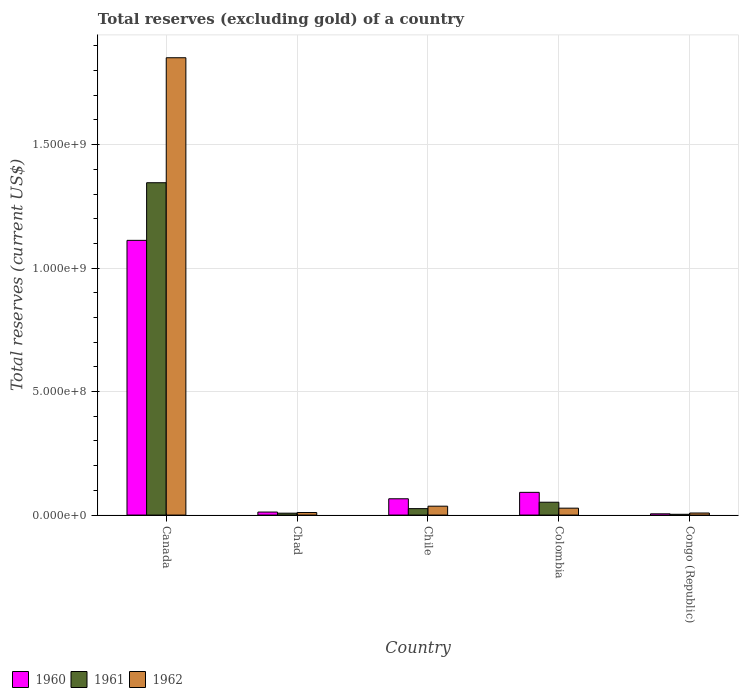How many groups of bars are there?
Make the answer very short. 5. Are the number of bars per tick equal to the number of legend labels?
Ensure brevity in your answer.  Yes. What is the label of the 5th group of bars from the left?
Your answer should be compact. Congo (Republic). In how many cases, is the number of bars for a given country not equal to the number of legend labels?
Offer a terse response. 0. What is the total reserves (excluding gold) in 1962 in Canada?
Make the answer very short. 1.85e+09. Across all countries, what is the maximum total reserves (excluding gold) in 1960?
Provide a succinct answer. 1.11e+09. Across all countries, what is the minimum total reserves (excluding gold) in 1962?
Your answer should be very brief. 8.38e+06. In which country was the total reserves (excluding gold) in 1962 minimum?
Your answer should be very brief. Congo (Republic). What is the total total reserves (excluding gold) in 1961 in the graph?
Provide a short and direct response. 1.43e+09. What is the difference between the total reserves (excluding gold) in 1960 in Colombia and that in Congo (Republic)?
Give a very brief answer. 8.69e+07. What is the difference between the total reserves (excluding gold) in 1960 in Colombia and the total reserves (excluding gold) in 1961 in Chile?
Make the answer very short. 6.59e+07. What is the average total reserves (excluding gold) in 1960 per country?
Provide a succinct answer. 2.58e+08. What is the difference between the total reserves (excluding gold) of/in 1960 and total reserves (excluding gold) of/in 1962 in Congo (Republic)?
Offer a terse response. -3.32e+06. In how many countries, is the total reserves (excluding gold) in 1962 greater than 1800000000 US$?
Provide a short and direct response. 1. What is the ratio of the total reserves (excluding gold) in 1962 in Chad to that in Colombia?
Your answer should be compact. 0.37. Is the total reserves (excluding gold) in 1961 in Chad less than that in Chile?
Offer a terse response. Yes. What is the difference between the highest and the second highest total reserves (excluding gold) in 1962?
Provide a succinct answer. 1.82e+09. What is the difference between the highest and the lowest total reserves (excluding gold) in 1962?
Ensure brevity in your answer.  1.84e+09. What does the 1st bar from the left in Canada represents?
Give a very brief answer. 1960. What is the difference between two consecutive major ticks on the Y-axis?
Give a very brief answer. 5.00e+08. Does the graph contain any zero values?
Ensure brevity in your answer.  No. Does the graph contain grids?
Your answer should be very brief. Yes. Where does the legend appear in the graph?
Provide a succinct answer. Bottom left. How many legend labels are there?
Offer a very short reply. 3. How are the legend labels stacked?
Keep it short and to the point. Horizontal. What is the title of the graph?
Your response must be concise. Total reserves (excluding gold) of a country. What is the label or title of the Y-axis?
Your answer should be very brief. Total reserves (current US$). What is the Total reserves (current US$) of 1960 in Canada?
Offer a terse response. 1.11e+09. What is the Total reserves (current US$) in 1961 in Canada?
Offer a terse response. 1.35e+09. What is the Total reserves (current US$) in 1962 in Canada?
Your response must be concise. 1.85e+09. What is the Total reserves (current US$) in 1960 in Chad?
Make the answer very short. 1.22e+07. What is the Total reserves (current US$) of 1961 in Chad?
Offer a terse response. 7.69e+06. What is the Total reserves (current US$) in 1962 in Chad?
Offer a very short reply. 1.03e+07. What is the Total reserves (current US$) in 1960 in Chile?
Your response must be concise. 6.60e+07. What is the Total reserves (current US$) of 1961 in Chile?
Offer a terse response. 2.61e+07. What is the Total reserves (current US$) in 1962 in Chile?
Provide a short and direct response. 3.60e+07. What is the Total reserves (current US$) in 1960 in Colombia?
Ensure brevity in your answer.  9.20e+07. What is the Total reserves (current US$) of 1961 in Colombia?
Keep it short and to the point. 5.20e+07. What is the Total reserves (current US$) in 1962 in Colombia?
Provide a short and direct response. 2.80e+07. What is the Total reserves (current US$) in 1960 in Congo (Republic)?
Provide a succinct answer. 5.06e+06. What is the Total reserves (current US$) of 1961 in Congo (Republic)?
Offer a terse response. 3.16e+06. What is the Total reserves (current US$) of 1962 in Congo (Republic)?
Your answer should be compact. 8.38e+06. Across all countries, what is the maximum Total reserves (current US$) of 1960?
Your response must be concise. 1.11e+09. Across all countries, what is the maximum Total reserves (current US$) of 1961?
Provide a succinct answer. 1.35e+09. Across all countries, what is the maximum Total reserves (current US$) of 1962?
Offer a very short reply. 1.85e+09. Across all countries, what is the minimum Total reserves (current US$) in 1960?
Your answer should be compact. 5.06e+06. Across all countries, what is the minimum Total reserves (current US$) of 1961?
Provide a short and direct response. 3.16e+06. Across all countries, what is the minimum Total reserves (current US$) of 1962?
Your answer should be compact. 8.38e+06. What is the total Total reserves (current US$) of 1960 in the graph?
Your answer should be compact. 1.29e+09. What is the total Total reserves (current US$) of 1961 in the graph?
Offer a very short reply. 1.43e+09. What is the total Total reserves (current US$) of 1962 in the graph?
Ensure brevity in your answer.  1.93e+09. What is the difference between the Total reserves (current US$) of 1960 in Canada and that in Chad?
Make the answer very short. 1.10e+09. What is the difference between the Total reserves (current US$) of 1961 in Canada and that in Chad?
Your answer should be very brief. 1.34e+09. What is the difference between the Total reserves (current US$) in 1962 in Canada and that in Chad?
Ensure brevity in your answer.  1.84e+09. What is the difference between the Total reserves (current US$) of 1960 in Canada and that in Chile?
Offer a terse response. 1.05e+09. What is the difference between the Total reserves (current US$) in 1961 in Canada and that in Chile?
Offer a very short reply. 1.32e+09. What is the difference between the Total reserves (current US$) in 1962 in Canada and that in Chile?
Offer a terse response. 1.82e+09. What is the difference between the Total reserves (current US$) of 1960 in Canada and that in Colombia?
Your response must be concise. 1.02e+09. What is the difference between the Total reserves (current US$) in 1961 in Canada and that in Colombia?
Your answer should be compact. 1.29e+09. What is the difference between the Total reserves (current US$) of 1962 in Canada and that in Colombia?
Provide a short and direct response. 1.82e+09. What is the difference between the Total reserves (current US$) in 1960 in Canada and that in Congo (Republic)?
Offer a terse response. 1.11e+09. What is the difference between the Total reserves (current US$) of 1961 in Canada and that in Congo (Republic)?
Your answer should be very brief. 1.34e+09. What is the difference between the Total reserves (current US$) in 1962 in Canada and that in Congo (Republic)?
Offer a very short reply. 1.84e+09. What is the difference between the Total reserves (current US$) of 1960 in Chad and that in Chile?
Give a very brief answer. -5.38e+07. What is the difference between the Total reserves (current US$) of 1961 in Chad and that in Chile?
Offer a very short reply. -1.84e+07. What is the difference between the Total reserves (current US$) in 1962 in Chad and that in Chile?
Your answer should be very brief. -2.57e+07. What is the difference between the Total reserves (current US$) in 1960 in Chad and that in Colombia?
Your answer should be very brief. -7.98e+07. What is the difference between the Total reserves (current US$) in 1961 in Chad and that in Colombia?
Your response must be concise. -4.43e+07. What is the difference between the Total reserves (current US$) in 1962 in Chad and that in Colombia?
Your answer should be compact. -1.77e+07. What is the difference between the Total reserves (current US$) in 1960 in Chad and that in Congo (Republic)?
Offer a very short reply. 7.18e+06. What is the difference between the Total reserves (current US$) in 1961 in Chad and that in Congo (Republic)?
Your response must be concise. 4.53e+06. What is the difference between the Total reserves (current US$) of 1962 in Chad and that in Congo (Republic)?
Keep it short and to the point. 1.92e+06. What is the difference between the Total reserves (current US$) in 1960 in Chile and that in Colombia?
Keep it short and to the point. -2.60e+07. What is the difference between the Total reserves (current US$) in 1961 in Chile and that in Colombia?
Your answer should be compact. -2.59e+07. What is the difference between the Total reserves (current US$) of 1960 in Chile and that in Congo (Republic)?
Keep it short and to the point. 6.09e+07. What is the difference between the Total reserves (current US$) of 1961 in Chile and that in Congo (Republic)?
Offer a terse response. 2.29e+07. What is the difference between the Total reserves (current US$) in 1962 in Chile and that in Congo (Republic)?
Offer a very short reply. 2.76e+07. What is the difference between the Total reserves (current US$) in 1960 in Colombia and that in Congo (Republic)?
Your answer should be very brief. 8.69e+07. What is the difference between the Total reserves (current US$) of 1961 in Colombia and that in Congo (Republic)?
Make the answer very short. 4.88e+07. What is the difference between the Total reserves (current US$) of 1962 in Colombia and that in Congo (Republic)?
Offer a terse response. 1.96e+07. What is the difference between the Total reserves (current US$) of 1960 in Canada and the Total reserves (current US$) of 1961 in Chad?
Ensure brevity in your answer.  1.10e+09. What is the difference between the Total reserves (current US$) in 1960 in Canada and the Total reserves (current US$) in 1962 in Chad?
Ensure brevity in your answer.  1.10e+09. What is the difference between the Total reserves (current US$) of 1961 in Canada and the Total reserves (current US$) of 1962 in Chad?
Make the answer very short. 1.34e+09. What is the difference between the Total reserves (current US$) in 1960 in Canada and the Total reserves (current US$) in 1961 in Chile?
Your answer should be very brief. 1.09e+09. What is the difference between the Total reserves (current US$) of 1960 in Canada and the Total reserves (current US$) of 1962 in Chile?
Offer a very short reply. 1.08e+09. What is the difference between the Total reserves (current US$) in 1961 in Canada and the Total reserves (current US$) in 1962 in Chile?
Keep it short and to the point. 1.31e+09. What is the difference between the Total reserves (current US$) in 1960 in Canada and the Total reserves (current US$) in 1961 in Colombia?
Your response must be concise. 1.06e+09. What is the difference between the Total reserves (current US$) of 1960 in Canada and the Total reserves (current US$) of 1962 in Colombia?
Make the answer very short. 1.08e+09. What is the difference between the Total reserves (current US$) in 1961 in Canada and the Total reserves (current US$) in 1962 in Colombia?
Provide a short and direct response. 1.32e+09. What is the difference between the Total reserves (current US$) in 1960 in Canada and the Total reserves (current US$) in 1961 in Congo (Republic)?
Provide a short and direct response. 1.11e+09. What is the difference between the Total reserves (current US$) in 1960 in Canada and the Total reserves (current US$) in 1962 in Congo (Republic)?
Your answer should be compact. 1.10e+09. What is the difference between the Total reserves (current US$) of 1961 in Canada and the Total reserves (current US$) of 1962 in Congo (Republic)?
Your answer should be very brief. 1.34e+09. What is the difference between the Total reserves (current US$) of 1960 in Chad and the Total reserves (current US$) of 1961 in Chile?
Provide a short and direct response. -1.39e+07. What is the difference between the Total reserves (current US$) in 1960 in Chad and the Total reserves (current US$) in 1962 in Chile?
Provide a short and direct response. -2.38e+07. What is the difference between the Total reserves (current US$) in 1961 in Chad and the Total reserves (current US$) in 1962 in Chile?
Provide a succinct answer. -2.83e+07. What is the difference between the Total reserves (current US$) in 1960 in Chad and the Total reserves (current US$) in 1961 in Colombia?
Provide a short and direct response. -3.98e+07. What is the difference between the Total reserves (current US$) of 1960 in Chad and the Total reserves (current US$) of 1962 in Colombia?
Your answer should be compact. -1.58e+07. What is the difference between the Total reserves (current US$) of 1961 in Chad and the Total reserves (current US$) of 1962 in Colombia?
Your answer should be compact. -2.03e+07. What is the difference between the Total reserves (current US$) of 1960 in Chad and the Total reserves (current US$) of 1961 in Congo (Republic)?
Make the answer very short. 9.08e+06. What is the difference between the Total reserves (current US$) in 1960 in Chad and the Total reserves (current US$) in 1962 in Congo (Republic)?
Your answer should be compact. 3.86e+06. What is the difference between the Total reserves (current US$) in 1961 in Chad and the Total reserves (current US$) in 1962 in Congo (Republic)?
Your answer should be compact. -6.90e+05. What is the difference between the Total reserves (current US$) of 1960 in Chile and the Total reserves (current US$) of 1961 in Colombia?
Provide a short and direct response. 1.40e+07. What is the difference between the Total reserves (current US$) of 1960 in Chile and the Total reserves (current US$) of 1962 in Colombia?
Ensure brevity in your answer.  3.80e+07. What is the difference between the Total reserves (current US$) in 1961 in Chile and the Total reserves (current US$) in 1962 in Colombia?
Your answer should be compact. -1.90e+06. What is the difference between the Total reserves (current US$) in 1960 in Chile and the Total reserves (current US$) in 1961 in Congo (Republic)?
Your answer should be very brief. 6.28e+07. What is the difference between the Total reserves (current US$) of 1960 in Chile and the Total reserves (current US$) of 1962 in Congo (Republic)?
Your response must be concise. 5.76e+07. What is the difference between the Total reserves (current US$) of 1961 in Chile and the Total reserves (current US$) of 1962 in Congo (Republic)?
Make the answer very short. 1.77e+07. What is the difference between the Total reserves (current US$) of 1960 in Colombia and the Total reserves (current US$) of 1961 in Congo (Republic)?
Offer a terse response. 8.88e+07. What is the difference between the Total reserves (current US$) in 1960 in Colombia and the Total reserves (current US$) in 1962 in Congo (Republic)?
Provide a succinct answer. 8.36e+07. What is the difference between the Total reserves (current US$) in 1961 in Colombia and the Total reserves (current US$) in 1962 in Congo (Republic)?
Give a very brief answer. 4.36e+07. What is the average Total reserves (current US$) in 1960 per country?
Give a very brief answer. 2.58e+08. What is the average Total reserves (current US$) in 1961 per country?
Give a very brief answer. 2.87e+08. What is the average Total reserves (current US$) in 1962 per country?
Provide a succinct answer. 3.87e+08. What is the difference between the Total reserves (current US$) of 1960 and Total reserves (current US$) of 1961 in Canada?
Offer a very short reply. -2.33e+08. What is the difference between the Total reserves (current US$) in 1960 and Total reserves (current US$) in 1962 in Canada?
Your response must be concise. -7.39e+08. What is the difference between the Total reserves (current US$) of 1961 and Total reserves (current US$) of 1962 in Canada?
Offer a terse response. -5.06e+08. What is the difference between the Total reserves (current US$) in 1960 and Total reserves (current US$) in 1961 in Chad?
Give a very brief answer. 4.55e+06. What is the difference between the Total reserves (current US$) of 1960 and Total reserves (current US$) of 1962 in Chad?
Give a very brief answer. 1.94e+06. What is the difference between the Total reserves (current US$) in 1961 and Total reserves (current US$) in 1962 in Chad?
Make the answer very short. -2.61e+06. What is the difference between the Total reserves (current US$) in 1960 and Total reserves (current US$) in 1961 in Chile?
Offer a terse response. 3.99e+07. What is the difference between the Total reserves (current US$) in 1960 and Total reserves (current US$) in 1962 in Chile?
Provide a succinct answer. 3.00e+07. What is the difference between the Total reserves (current US$) of 1961 and Total reserves (current US$) of 1962 in Chile?
Ensure brevity in your answer.  -9.90e+06. What is the difference between the Total reserves (current US$) in 1960 and Total reserves (current US$) in 1961 in Colombia?
Ensure brevity in your answer.  4.00e+07. What is the difference between the Total reserves (current US$) in 1960 and Total reserves (current US$) in 1962 in Colombia?
Your answer should be very brief. 6.40e+07. What is the difference between the Total reserves (current US$) in 1961 and Total reserves (current US$) in 1962 in Colombia?
Your response must be concise. 2.40e+07. What is the difference between the Total reserves (current US$) in 1960 and Total reserves (current US$) in 1961 in Congo (Republic)?
Provide a succinct answer. 1.90e+06. What is the difference between the Total reserves (current US$) of 1960 and Total reserves (current US$) of 1962 in Congo (Republic)?
Provide a succinct answer. -3.32e+06. What is the difference between the Total reserves (current US$) in 1961 and Total reserves (current US$) in 1962 in Congo (Republic)?
Keep it short and to the point. -5.22e+06. What is the ratio of the Total reserves (current US$) in 1960 in Canada to that in Chad?
Ensure brevity in your answer.  90.89. What is the ratio of the Total reserves (current US$) of 1961 in Canada to that in Chad?
Give a very brief answer. 175.01. What is the ratio of the Total reserves (current US$) in 1962 in Canada to that in Chad?
Make the answer very short. 179.81. What is the ratio of the Total reserves (current US$) in 1960 in Canada to that in Chile?
Offer a terse response. 16.86. What is the ratio of the Total reserves (current US$) of 1961 in Canada to that in Chile?
Give a very brief answer. 51.56. What is the ratio of the Total reserves (current US$) in 1962 in Canada to that in Chile?
Keep it short and to the point. 51.44. What is the ratio of the Total reserves (current US$) of 1960 in Canada to that in Colombia?
Your answer should be compact. 12.09. What is the ratio of the Total reserves (current US$) of 1961 in Canada to that in Colombia?
Offer a terse response. 25.88. What is the ratio of the Total reserves (current US$) of 1962 in Canada to that in Colombia?
Your response must be concise. 66.14. What is the ratio of the Total reserves (current US$) of 1960 in Canada to that in Congo (Republic)?
Your response must be concise. 219.87. What is the ratio of the Total reserves (current US$) of 1961 in Canada to that in Congo (Republic)?
Provide a short and direct response. 425.9. What is the ratio of the Total reserves (current US$) of 1962 in Canada to that in Congo (Republic)?
Your answer should be compact. 221. What is the ratio of the Total reserves (current US$) in 1960 in Chad to that in Chile?
Ensure brevity in your answer.  0.19. What is the ratio of the Total reserves (current US$) in 1961 in Chad to that in Chile?
Ensure brevity in your answer.  0.29. What is the ratio of the Total reserves (current US$) in 1962 in Chad to that in Chile?
Make the answer very short. 0.29. What is the ratio of the Total reserves (current US$) of 1960 in Chad to that in Colombia?
Your answer should be compact. 0.13. What is the ratio of the Total reserves (current US$) in 1961 in Chad to that in Colombia?
Provide a succinct answer. 0.15. What is the ratio of the Total reserves (current US$) in 1962 in Chad to that in Colombia?
Keep it short and to the point. 0.37. What is the ratio of the Total reserves (current US$) of 1960 in Chad to that in Congo (Republic)?
Your response must be concise. 2.42. What is the ratio of the Total reserves (current US$) in 1961 in Chad to that in Congo (Republic)?
Give a very brief answer. 2.43. What is the ratio of the Total reserves (current US$) of 1962 in Chad to that in Congo (Republic)?
Your response must be concise. 1.23. What is the ratio of the Total reserves (current US$) of 1960 in Chile to that in Colombia?
Keep it short and to the point. 0.72. What is the ratio of the Total reserves (current US$) in 1961 in Chile to that in Colombia?
Provide a short and direct response. 0.5. What is the ratio of the Total reserves (current US$) in 1962 in Chile to that in Colombia?
Your answer should be very brief. 1.29. What is the ratio of the Total reserves (current US$) in 1960 in Chile to that in Congo (Republic)?
Give a very brief answer. 13.04. What is the ratio of the Total reserves (current US$) in 1961 in Chile to that in Congo (Republic)?
Make the answer very short. 8.26. What is the ratio of the Total reserves (current US$) of 1962 in Chile to that in Congo (Republic)?
Offer a very short reply. 4.3. What is the ratio of the Total reserves (current US$) of 1960 in Colombia to that in Congo (Republic)?
Offer a terse response. 18.18. What is the ratio of the Total reserves (current US$) of 1961 in Colombia to that in Congo (Republic)?
Your answer should be compact. 16.46. What is the ratio of the Total reserves (current US$) in 1962 in Colombia to that in Congo (Republic)?
Your answer should be compact. 3.34. What is the difference between the highest and the second highest Total reserves (current US$) in 1960?
Offer a very short reply. 1.02e+09. What is the difference between the highest and the second highest Total reserves (current US$) in 1961?
Your answer should be very brief. 1.29e+09. What is the difference between the highest and the second highest Total reserves (current US$) of 1962?
Provide a succinct answer. 1.82e+09. What is the difference between the highest and the lowest Total reserves (current US$) of 1960?
Offer a very short reply. 1.11e+09. What is the difference between the highest and the lowest Total reserves (current US$) of 1961?
Provide a succinct answer. 1.34e+09. What is the difference between the highest and the lowest Total reserves (current US$) in 1962?
Offer a terse response. 1.84e+09. 